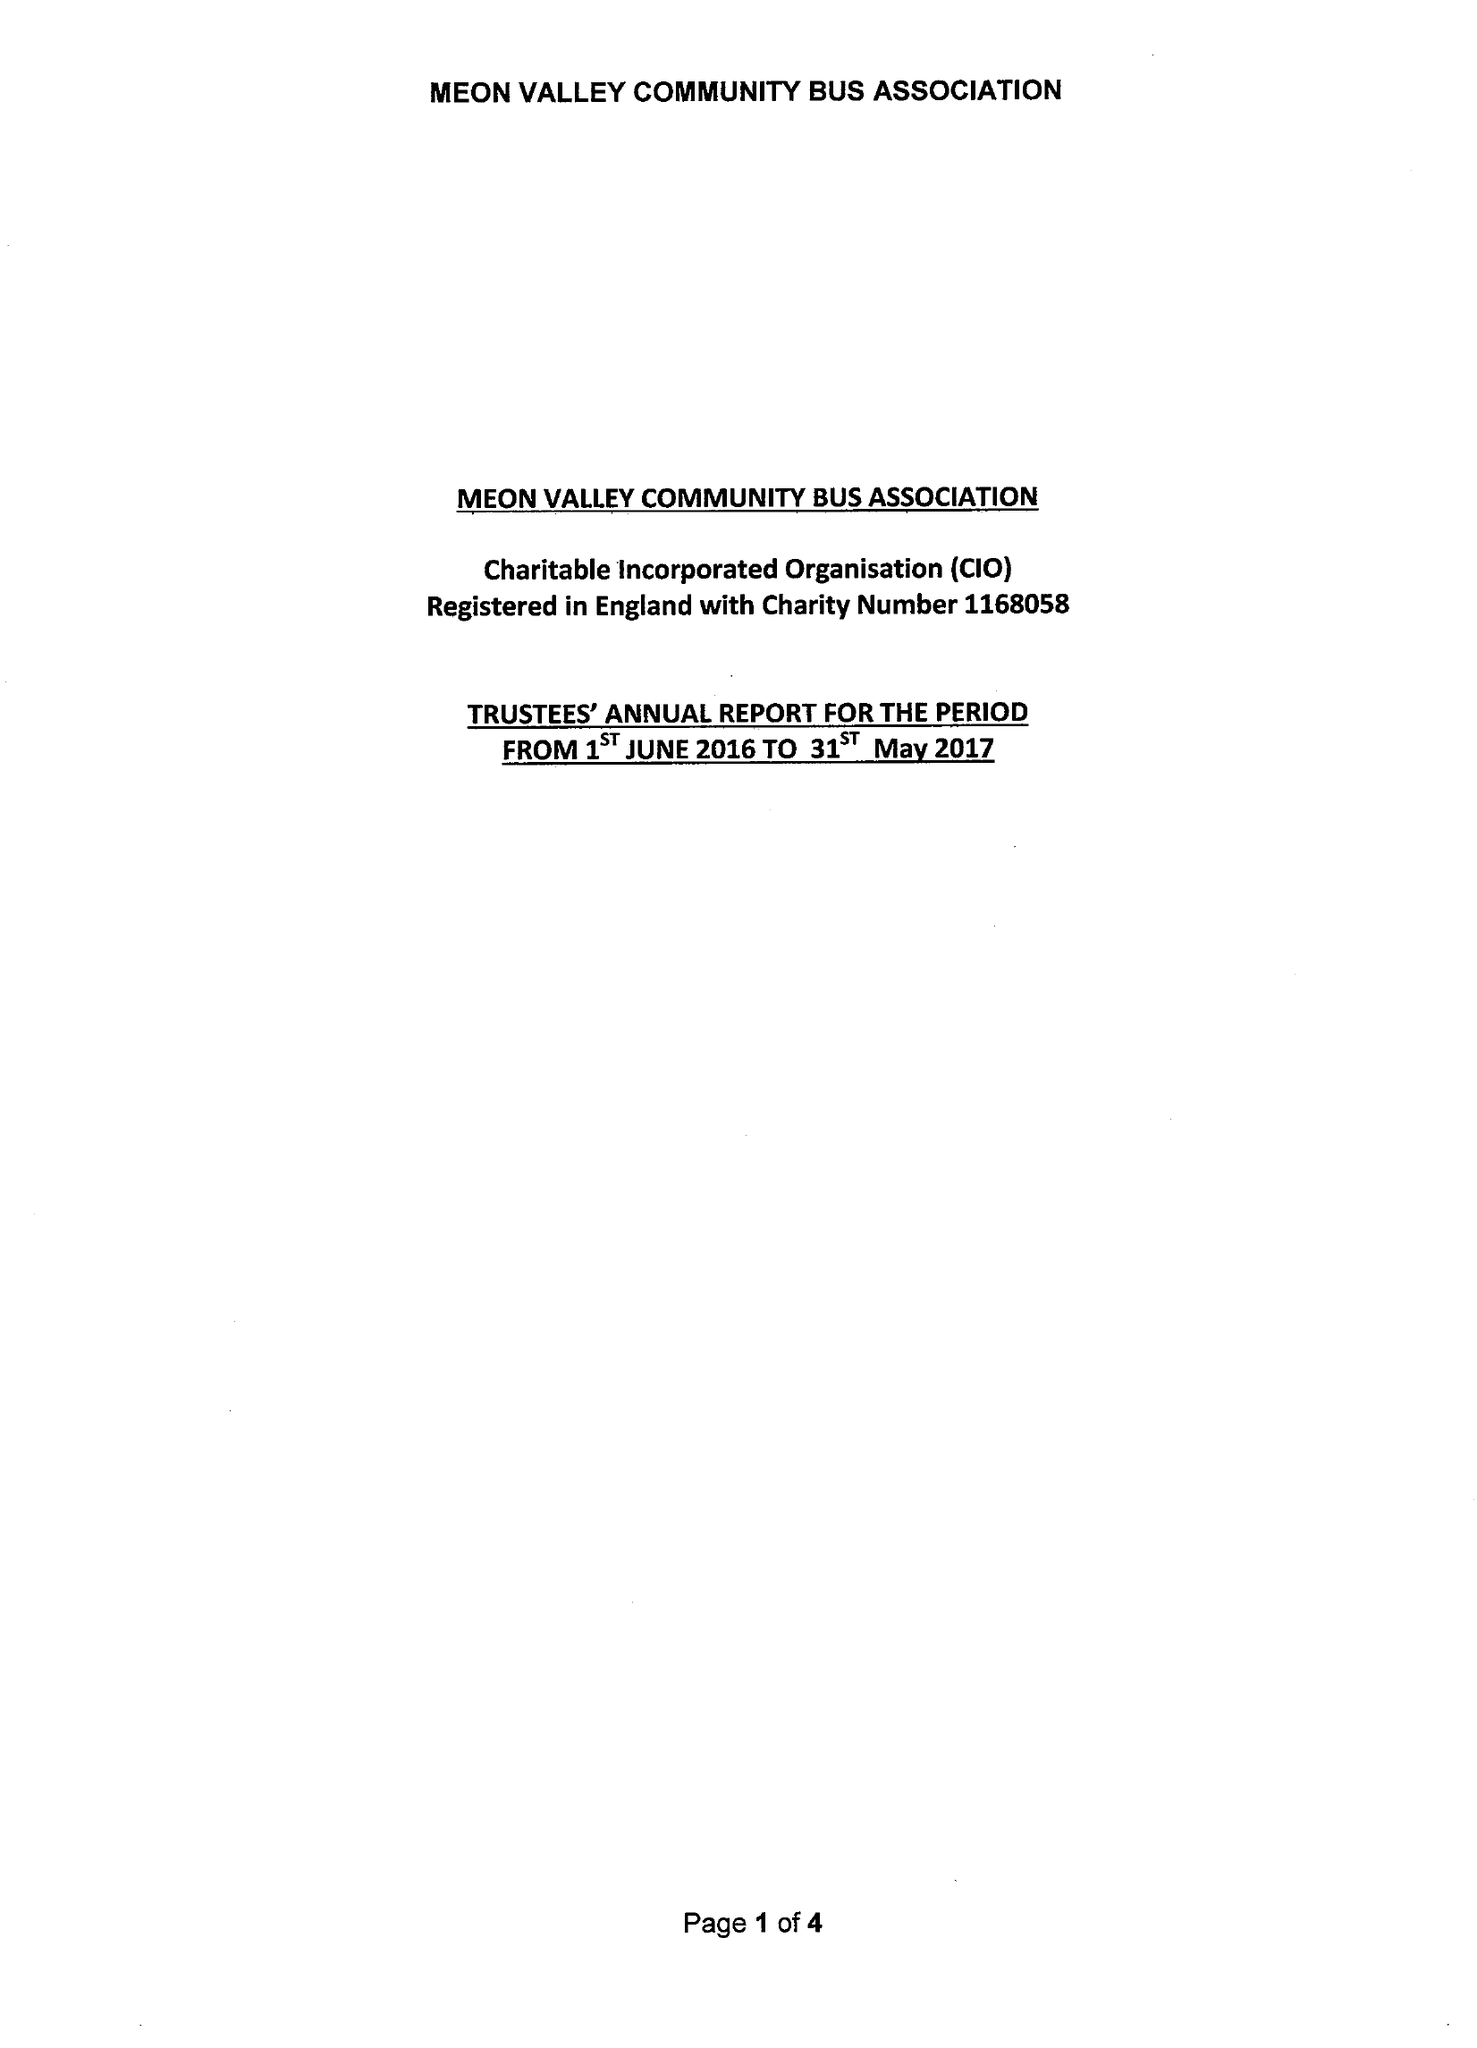What is the value for the charity_number?
Answer the question using a single word or phrase. 1168058 